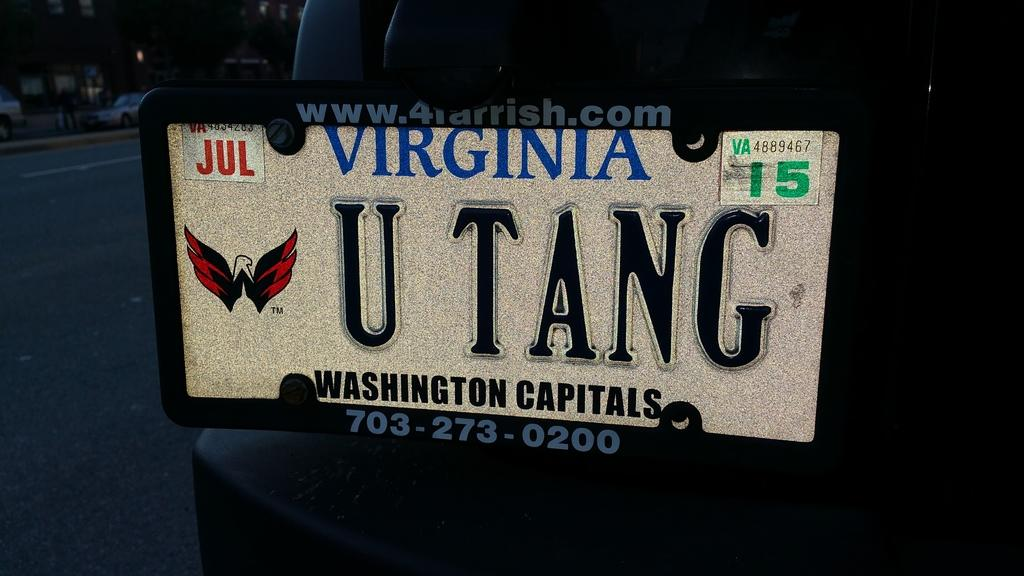What is the main subject in the center of the image? There is a car in the center of the image. Can you describe any specific details about the car? The car has a visible number plate. What else can be seen on the left side of the image? There is a person standing on the left side of the image. Are there any other vehicles visible in the image? Yes, there is another car visible in the image. What type of surface is the car and person standing on? There is a road in the image. How many cattle are grazing on the side of the road in the image? There are no cattle present in the image; it only features a car, a person, and another car on a road. 